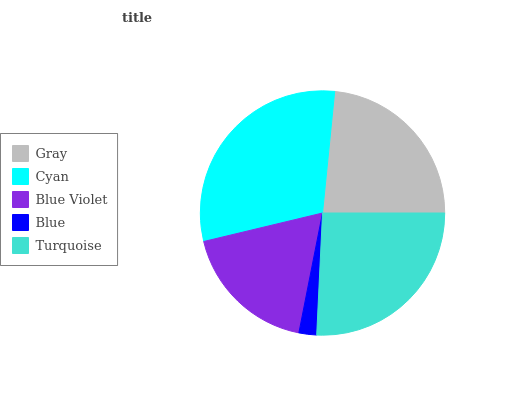Is Blue the minimum?
Answer yes or no. Yes. Is Cyan the maximum?
Answer yes or no. Yes. Is Blue Violet the minimum?
Answer yes or no. No. Is Blue Violet the maximum?
Answer yes or no. No. Is Cyan greater than Blue Violet?
Answer yes or no. Yes. Is Blue Violet less than Cyan?
Answer yes or no. Yes. Is Blue Violet greater than Cyan?
Answer yes or no. No. Is Cyan less than Blue Violet?
Answer yes or no. No. Is Gray the high median?
Answer yes or no. Yes. Is Gray the low median?
Answer yes or no. Yes. Is Cyan the high median?
Answer yes or no. No. Is Cyan the low median?
Answer yes or no. No. 